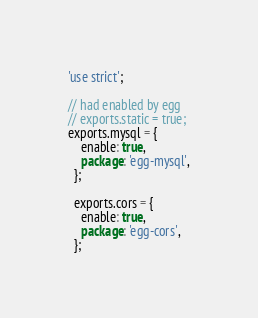Convert code to text. <code><loc_0><loc_0><loc_500><loc_500><_JavaScript_>'use strict';

// had enabled by egg
// exports.static = true;
exports.mysql = {
    enable: true,
    package: 'egg-mysql',
  };

  exports.cors = {
    enable: true,
    package: 'egg-cors',
  };</code> 